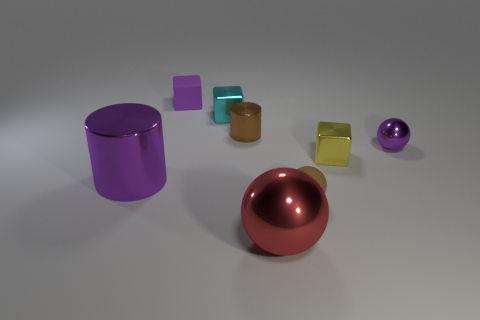Add 1 brown matte objects. How many objects exist? 9 Subtract all balls. How many objects are left? 5 Subtract 0 green balls. How many objects are left? 8 Subtract all small purple matte balls. Subtract all red metal spheres. How many objects are left? 7 Add 4 large metal cylinders. How many large metal cylinders are left? 5 Add 4 small green rubber blocks. How many small green rubber blocks exist? 4 